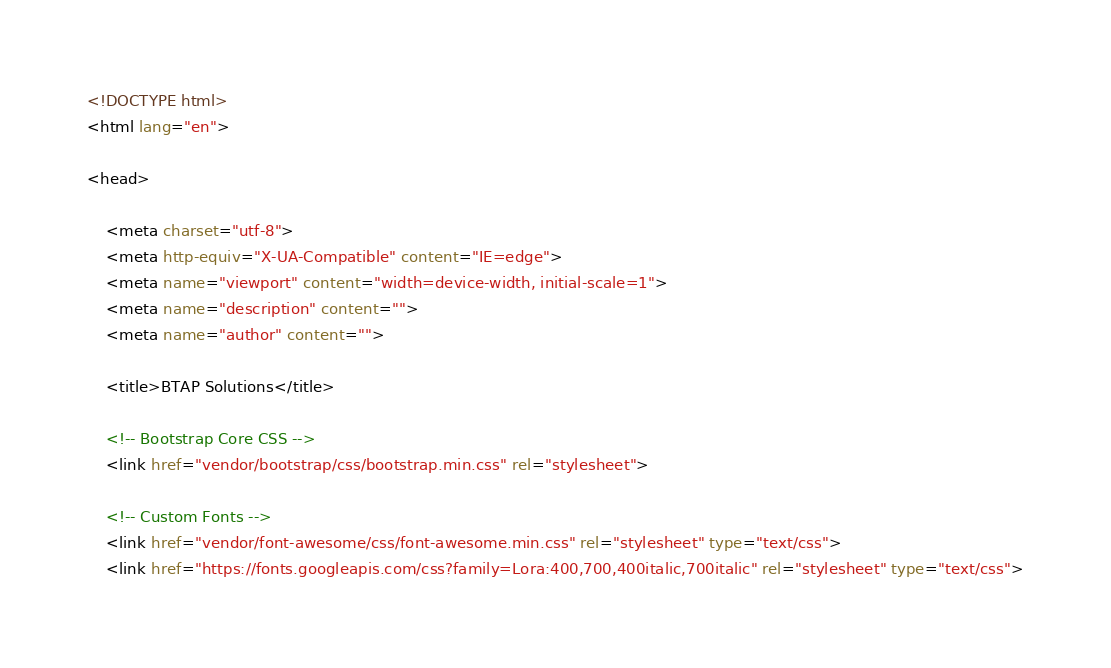Convert code to text. <code><loc_0><loc_0><loc_500><loc_500><_HTML_><!DOCTYPE html>
<html lang="en">

<head>

    <meta charset="utf-8">
    <meta http-equiv="X-UA-Compatible" content="IE=edge">
    <meta name="viewport" content="width=device-width, initial-scale=1">
    <meta name="description" content="">
    <meta name="author" content="">

    <title>BTAP Solutions</title>

    <!-- Bootstrap Core CSS -->
    <link href="vendor/bootstrap/css/bootstrap.min.css" rel="stylesheet">

    <!-- Custom Fonts -->
    <link href="vendor/font-awesome/css/font-awesome.min.css" rel="stylesheet" type="text/css">
    <link href="https://fonts.googleapis.com/css?family=Lora:400,700,400italic,700italic" rel="stylesheet" type="text/css"></code> 